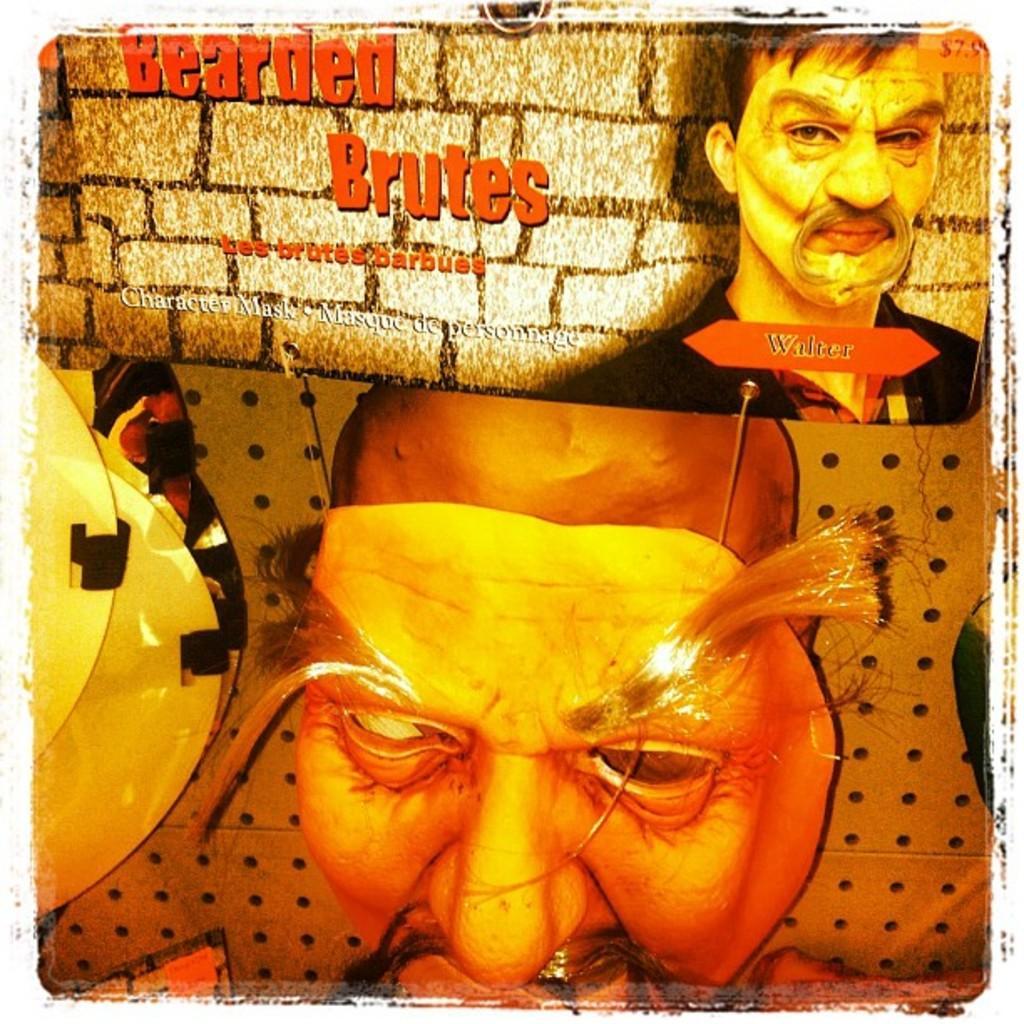Can you describe this image briefly? This is a picture of poster. We can see people and some information. 